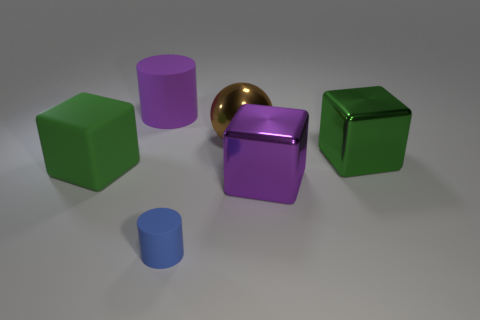Is there any other thing that has the same shape as the tiny blue object?
Your response must be concise. Yes. What is the shape of the big matte object that is on the left side of the purple rubber cylinder?
Provide a short and direct response. Cube. What is the shape of the big purple thing that is to the right of the purple object behind the cube that is left of the large purple matte cylinder?
Offer a terse response. Cube. What number of things are small blue matte things or green matte things?
Ensure brevity in your answer.  2. Does the matte object that is right of the large purple rubber cylinder have the same shape as the large green thing to the left of the small object?
Offer a very short reply. No. What number of things are to the left of the brown sphere and behind the small object?
Keep it short and to the point. 2. How many other things are there of the same size as the blue object?
Ensure brevity in your answer.  0. There is a object that is in front of the green rubber thing and behind the blue cylinder; what material is it?
Give a very brief answer. Metal. Is the color of the tiny matte object the same as the big metal cube in front of the large green metallic block?
Provide a succinct answer. No. There is a rubber object that is the same shape as the purple shiny object; what size is it?
Make the answer very short. Large. 